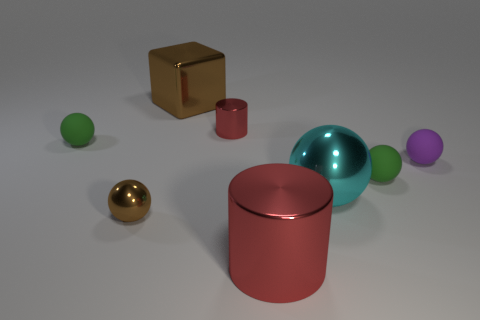Subtract all cyan balls. How many balls are left? 4 Subtract all brown balls. How many balls are left? 4 Subtract all red spheres. Subtract all brown blocks. How many spheres are left? 5 Add 1 large cylinders. How many objects exist? 9 Subtract all blocks. How many objects are left? 7 Add 1 blue cylinders. How many blue cylinders exist? 1 Subtract 0 yellow blocks. How many objects are left? 8 Subtract all small red metallic cylinders. Subtract all tiny brown shiny objects. How many objects are left? 6 Add 4 green matte spheres. How many green matte spheres are left? 6 